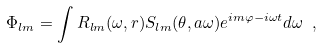Convert formula to latex. <formula><loc_0><loc_0><loc_500><loc_500>\Phi _ { l m } = \int R _ { l m } ( \omega , r ) S _ { l m } ( \theta , a \omega ) e ^ { i m \varphi - i \omega t } d \omega \ ,</formula> 